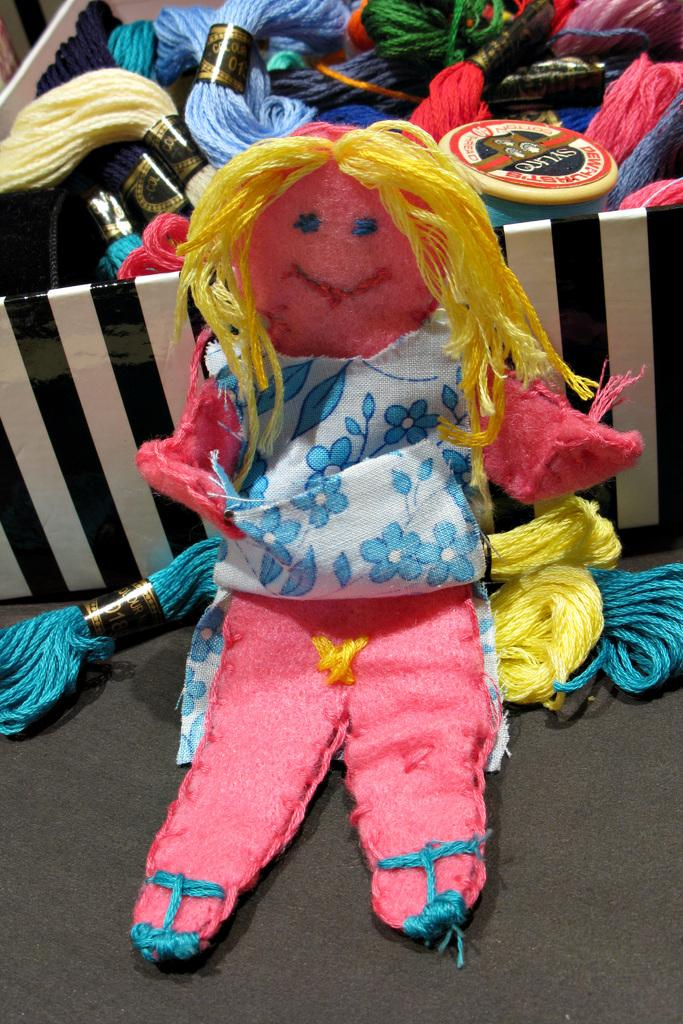What type of doll is in the picture? There is a doll made of wool in the picture. What can be seen behind the doll? There is a box behind the doll. What is inside the box? There are wool rolls inside the box. How many lizards can be seen crawling on the wool doll in the picture? There are no lizards present in the picture; it features a wool doll and a box with wool rolls. 